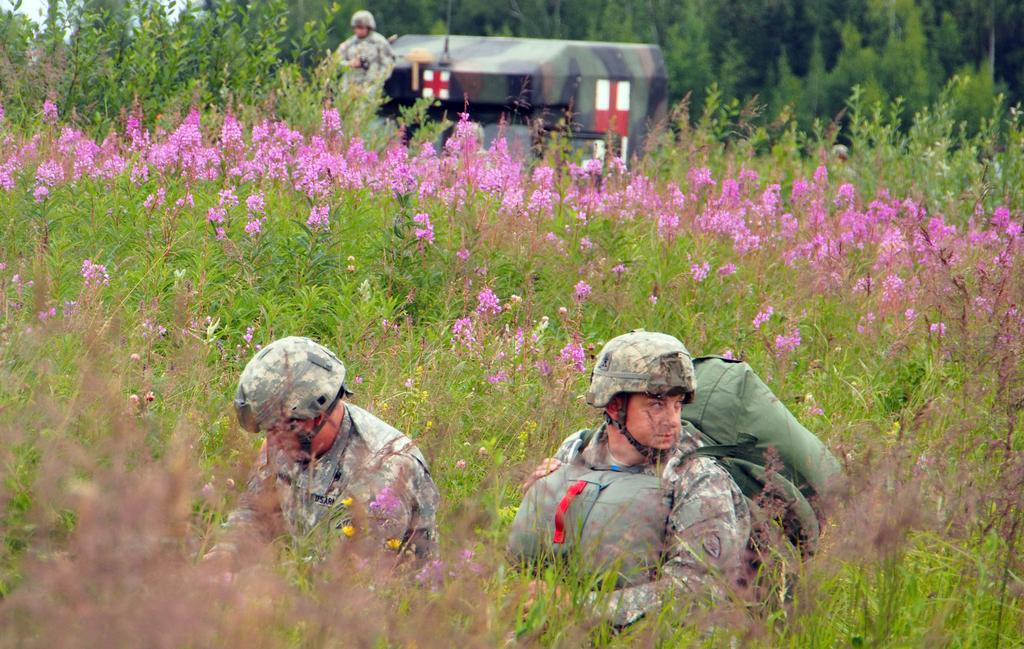What type of living organisms can be seen in the image? Plants are visible in the image. What protective gear are two people wearing in the image? Two people are wearing helmets in the image. What is the man carrying in the image? The man is carrying bags in the image. What can be seen in the background of the image? Flowers, trees, and a tent are visible in the background of the image. Can you describe the person standing in the background of the image? There is a person standing in the background of the image. What type of cheese is being used to create a spark in the image? There is no cheese or spark present in the image. How many legs can be seen on the person standing in the background of the image? The number of legs cannot be determined from the image, as only the person's upper body is visible. 